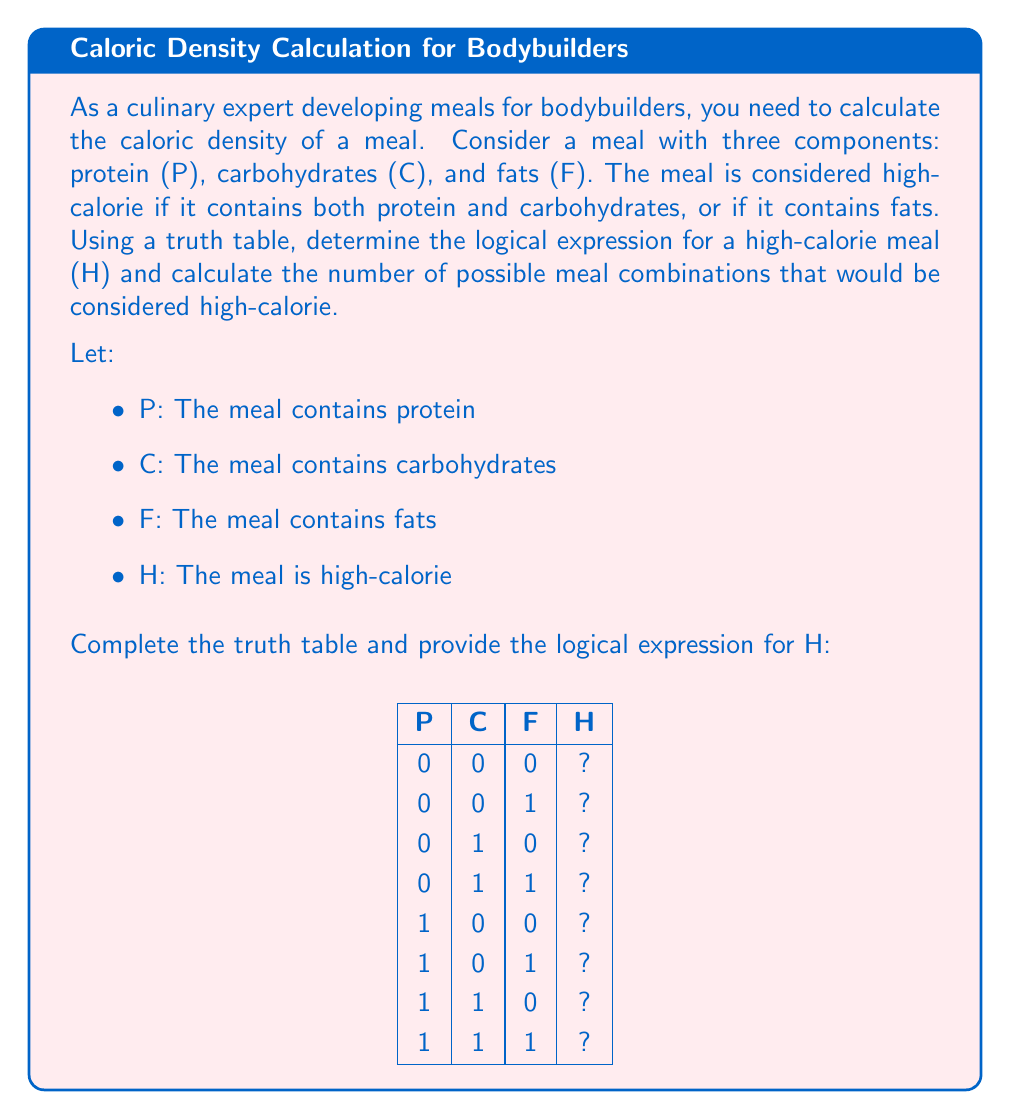Can you answer this question? To solve this problem, we need to follow these steps:

1. Complete the truth table:
   - H is true (1) if (P AND C) OR F is true
   - H is false (0) otherwise

$$
\begin{array}{|c|c|c|c|}
\hline
P & C & F & H \\
\hline
0 & 0 & 0 & 0 \\
0 & 0 & 1 & 1 \\
0 & 1 & 0 & 0 \\
0 & 1 & 1 & 1 \\
1 & 0 & 0 & 0 \\
1 & 0 & 1 & 1 \\
1 & 1 & 0 & 1 \\
1 & 1 & 1 & 1 \\
\hline
\end{array}
$$

2. Determine the logical expression for H:
   $H = (P \land C) \lor F$

3. Count the number of high-calorie meal combinations:
   There are 5 rows where H = 1, so there are 5 high-calorie meal combinations.

4. Express the answer as a fraction of total possible combinations:
   Total possible combinations = $2^3 = 8$ (since there are 3 binary variables)
   Fraction of high-calorie combinations = $\frac{5}{8}$
Answer: $H = (P \land C) \lor F$; $\frac{5}{8}$ of meal combinations are high-calorie 